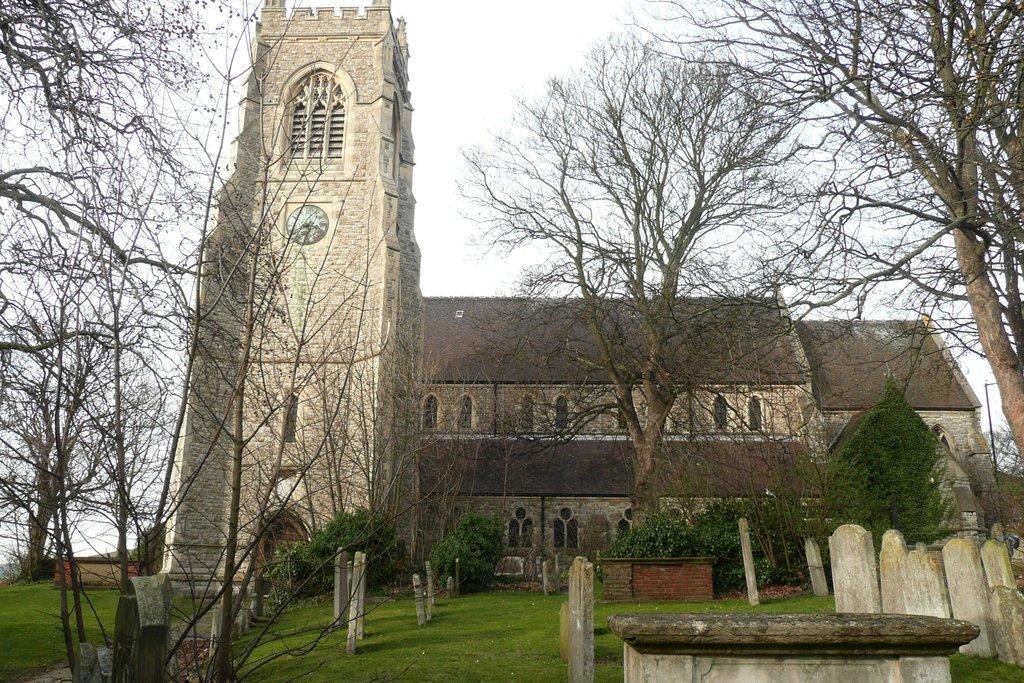Can you describe this image briefly? In the foreground of the picture there are gravestones, trees and plants. In the center of the picture there are trees, church and clock. Sky is cloudy. 